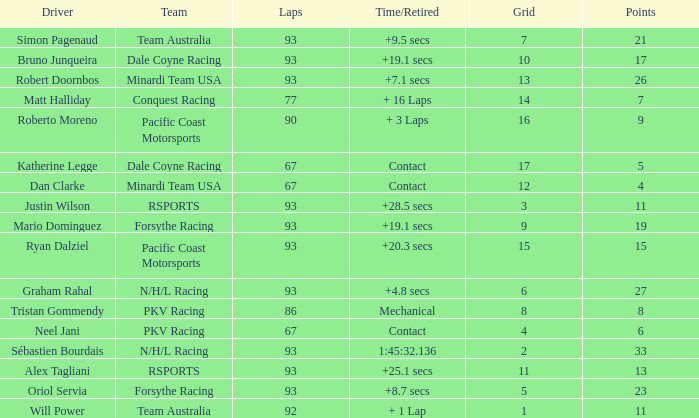What is the grid for the Minardi Team USA with laps smaller than 90? 12.0. 